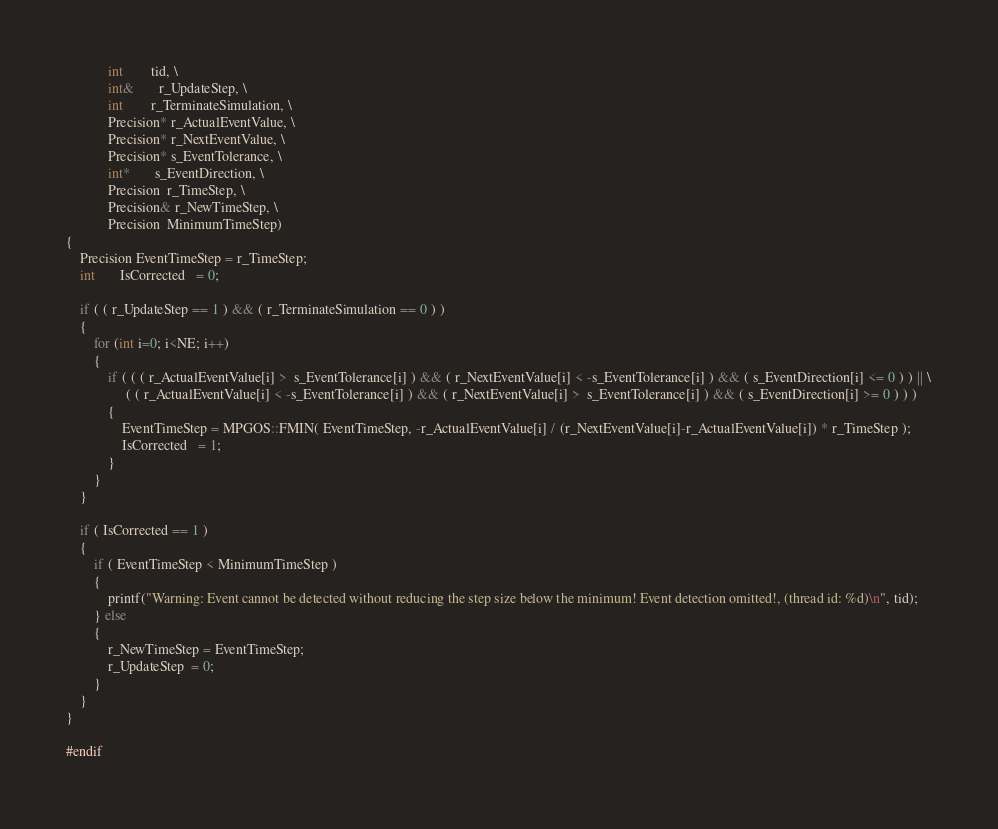<code> <loc_0><loc_0><loc_500><loc_500><_Cuda_>			int        tid, \
			int&       r_UpdateStep, \
			int        r_TerminateSimulation, \
			Precision* r_ActualEventValue, \
			Precision* r_NextEventValue, \
			Precision* s_EventTolerance, \
			int*       s_EventDirection, \
			Precision  r_TimeStep, \
			Precision& r_NewTimeStep, \
			Precision  MinimumTimeStep)
{
	Precision EventTimeStep = r_TimeStep;
	int       IsCorrected   = 0;
	
	if ( ( r_UpdateStep == 1 ) && ( r_TerminateSimulation == 0 ) )
	{
		for (int i=0; i<NE; i++)
		{
			if ( ( ( r_ActualEventValue[i] >  s_EventTolerance[i] ) && ( r_NextEventValue[i] < -s_EventTolerance[i] ) && ( s_EventDirection[i] <= 0 ) ) || \
				 ( ( r_ActualEventValue[i] < -s_EventTolerance[i] ) && ( r_NextEventValue[i] >  s_EventTolerance[i] ) && ( s_EventDirection[i] >= 0 ) ) )
			{
				EventTimeStep = MPGOS::FMIN( EventTimeStep, -r_ActualEventValue[i] / (r_NextEventValue[i]-r_ActualEventValue[i]) * r_TimeStep );
				IsCorrected   = 1;
			}
		}
	}
	
	if ( IsCorrected == 1 )
	{
		if ( EventTimeStep < MinimumTimeStep )
		{
			printf("Warning: Event cannot be detected without reducing the step size below the minimum! Event detection omitted!, (thread id: %d)\n", tid);
		} else
		{
			r_NewTimeStep = EventTimeStep;
			r_UpdateStep  = 0;
		}
	}
}

#endif</code> 